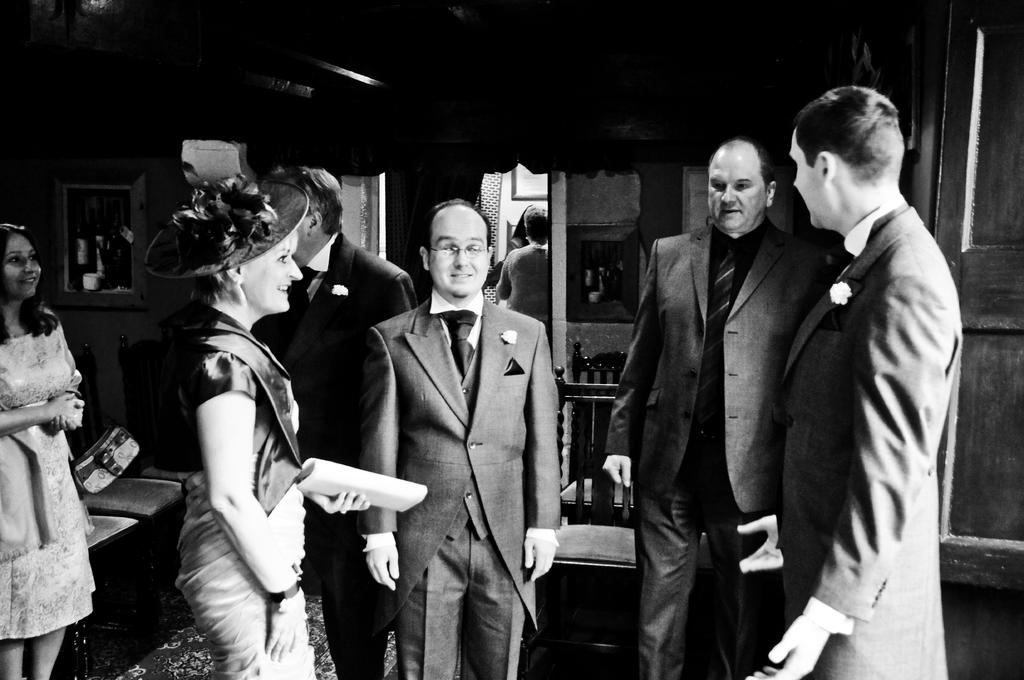What is the color scheme of the image? The image is black and white. What can be seen in the image besides the color scheme? There are people and chairs in the image. Are there any decorations or objects on the wall? Yes, pictures are present on the wall. Can you describe the position of one person in the image? One person is standing far away in the image, and there is a door visible behind them. What type of beef is being served at the camp in the image? There is no beef or camp present in the image; it features people, chairs, and pictures on the wall. Can you tell me how many socks are visible on the person standing far away? There are no socks visible on the person standing far away in the image. 